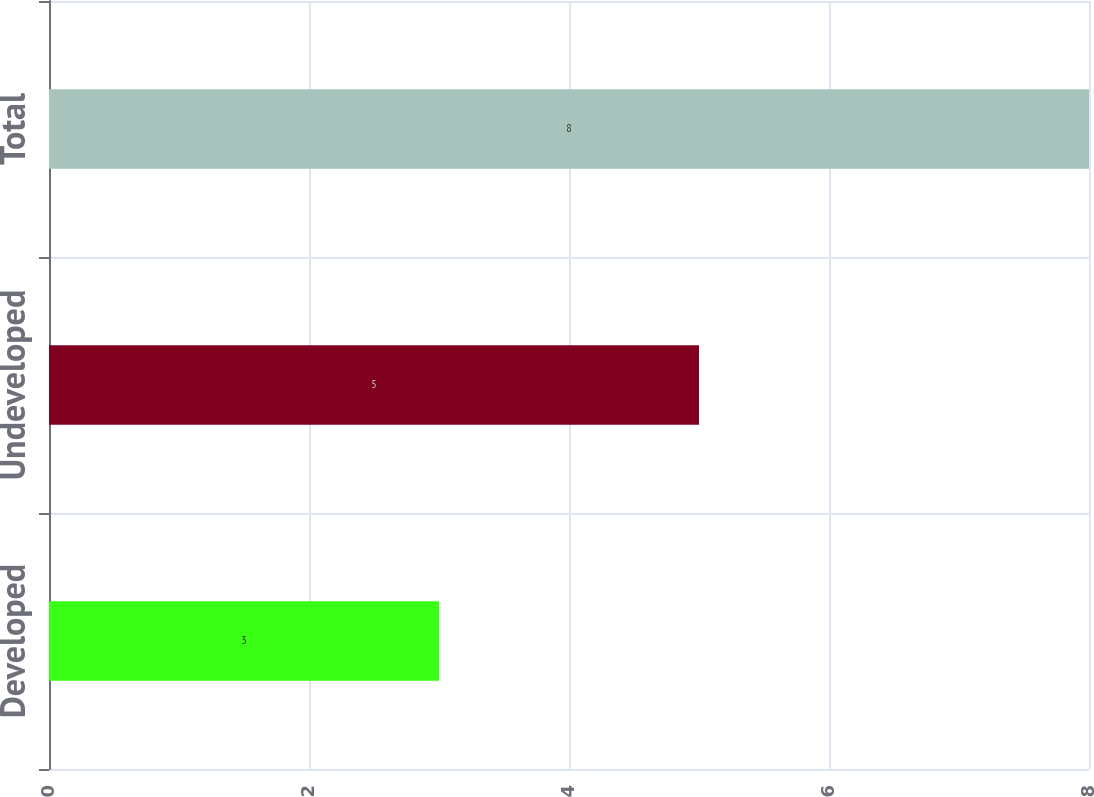<chart> <loc_0><loc_0><loc_500><loc_500><bar_chart><fcel>Developed<fcel>Undeveloped<fcel>Total<nl><fcel>3<fcel>5<fcel>8<nl></chart> 